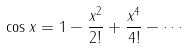Convert formula to latex. <formula><loc_0><loc_0><loc_500><loc_500>\cos x = 1 - { \frac { x ^ { 2 } } { 2 ! } } + { \frac { x ^ { 4 } } { 4 ! } } - \cdots</formula> 